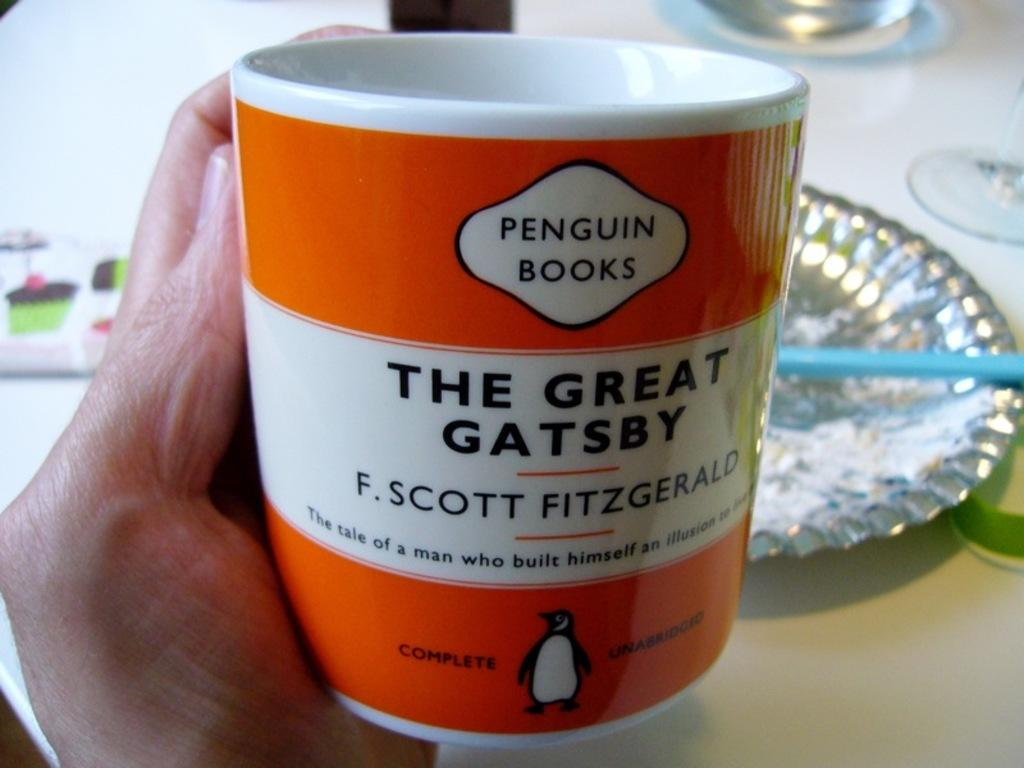What is the human hand holding in the image? The human hand is holding a cup in the image. What can be seen on the cup? The cup has text on it. What other objects are present on the table in the image? There are plates on the table in the image. What type of rake is being used to create an arch in the image? There is no rake or arch present in the image; it features a human hand holding a cup with text on it and plates on a table. 